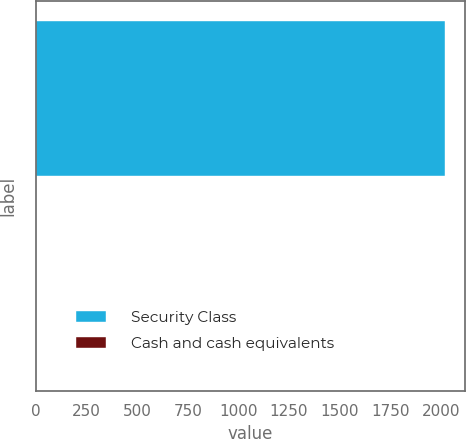Convert chart to OTSL. <chart><loc_0><loc_0><loc_500><loc_500><bar_chart><fcel>Security Class<fcel>Cash and cash equivalents<nl><fcel>2018<fcel>2.5<nl></chart> 